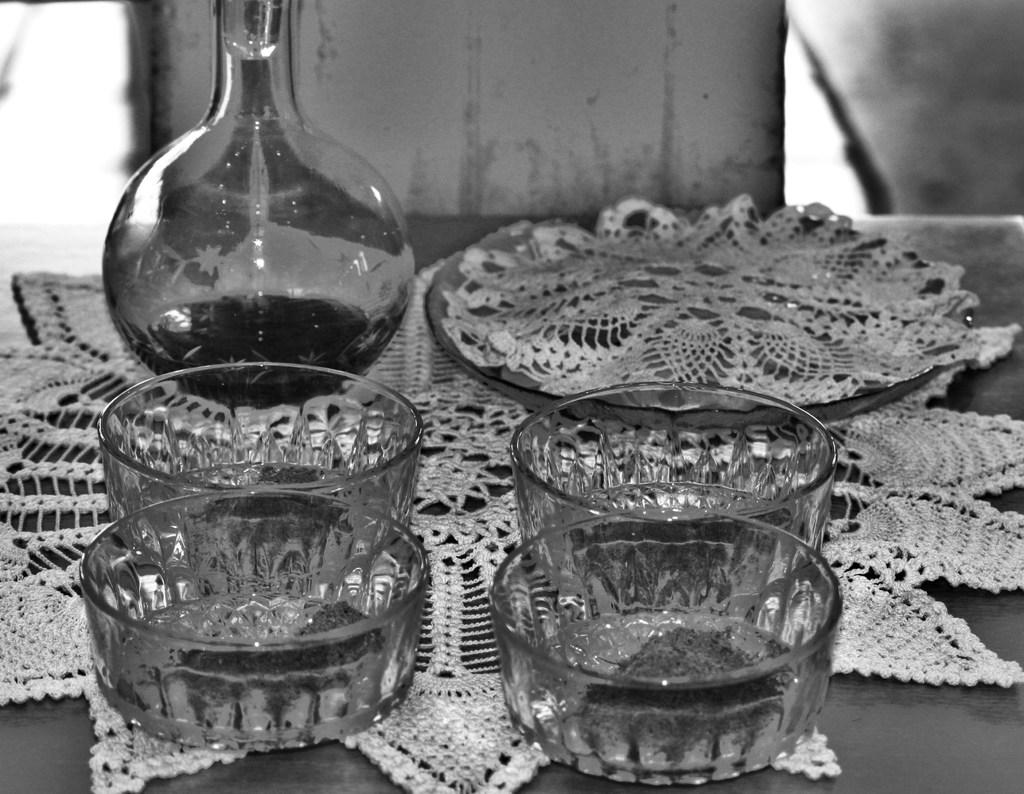What piece of furniture is present in the image? There is a table in the image. What items are on the table? There are hash trays and a bottle on the table. What type of milk is being poured from the bottle in the image? There is no milk present in the image; the bottle does not contain milk. 